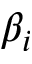<formula> <loc_0><loc_0><loc_500><loc_500>\beta _ { i }</formula> 